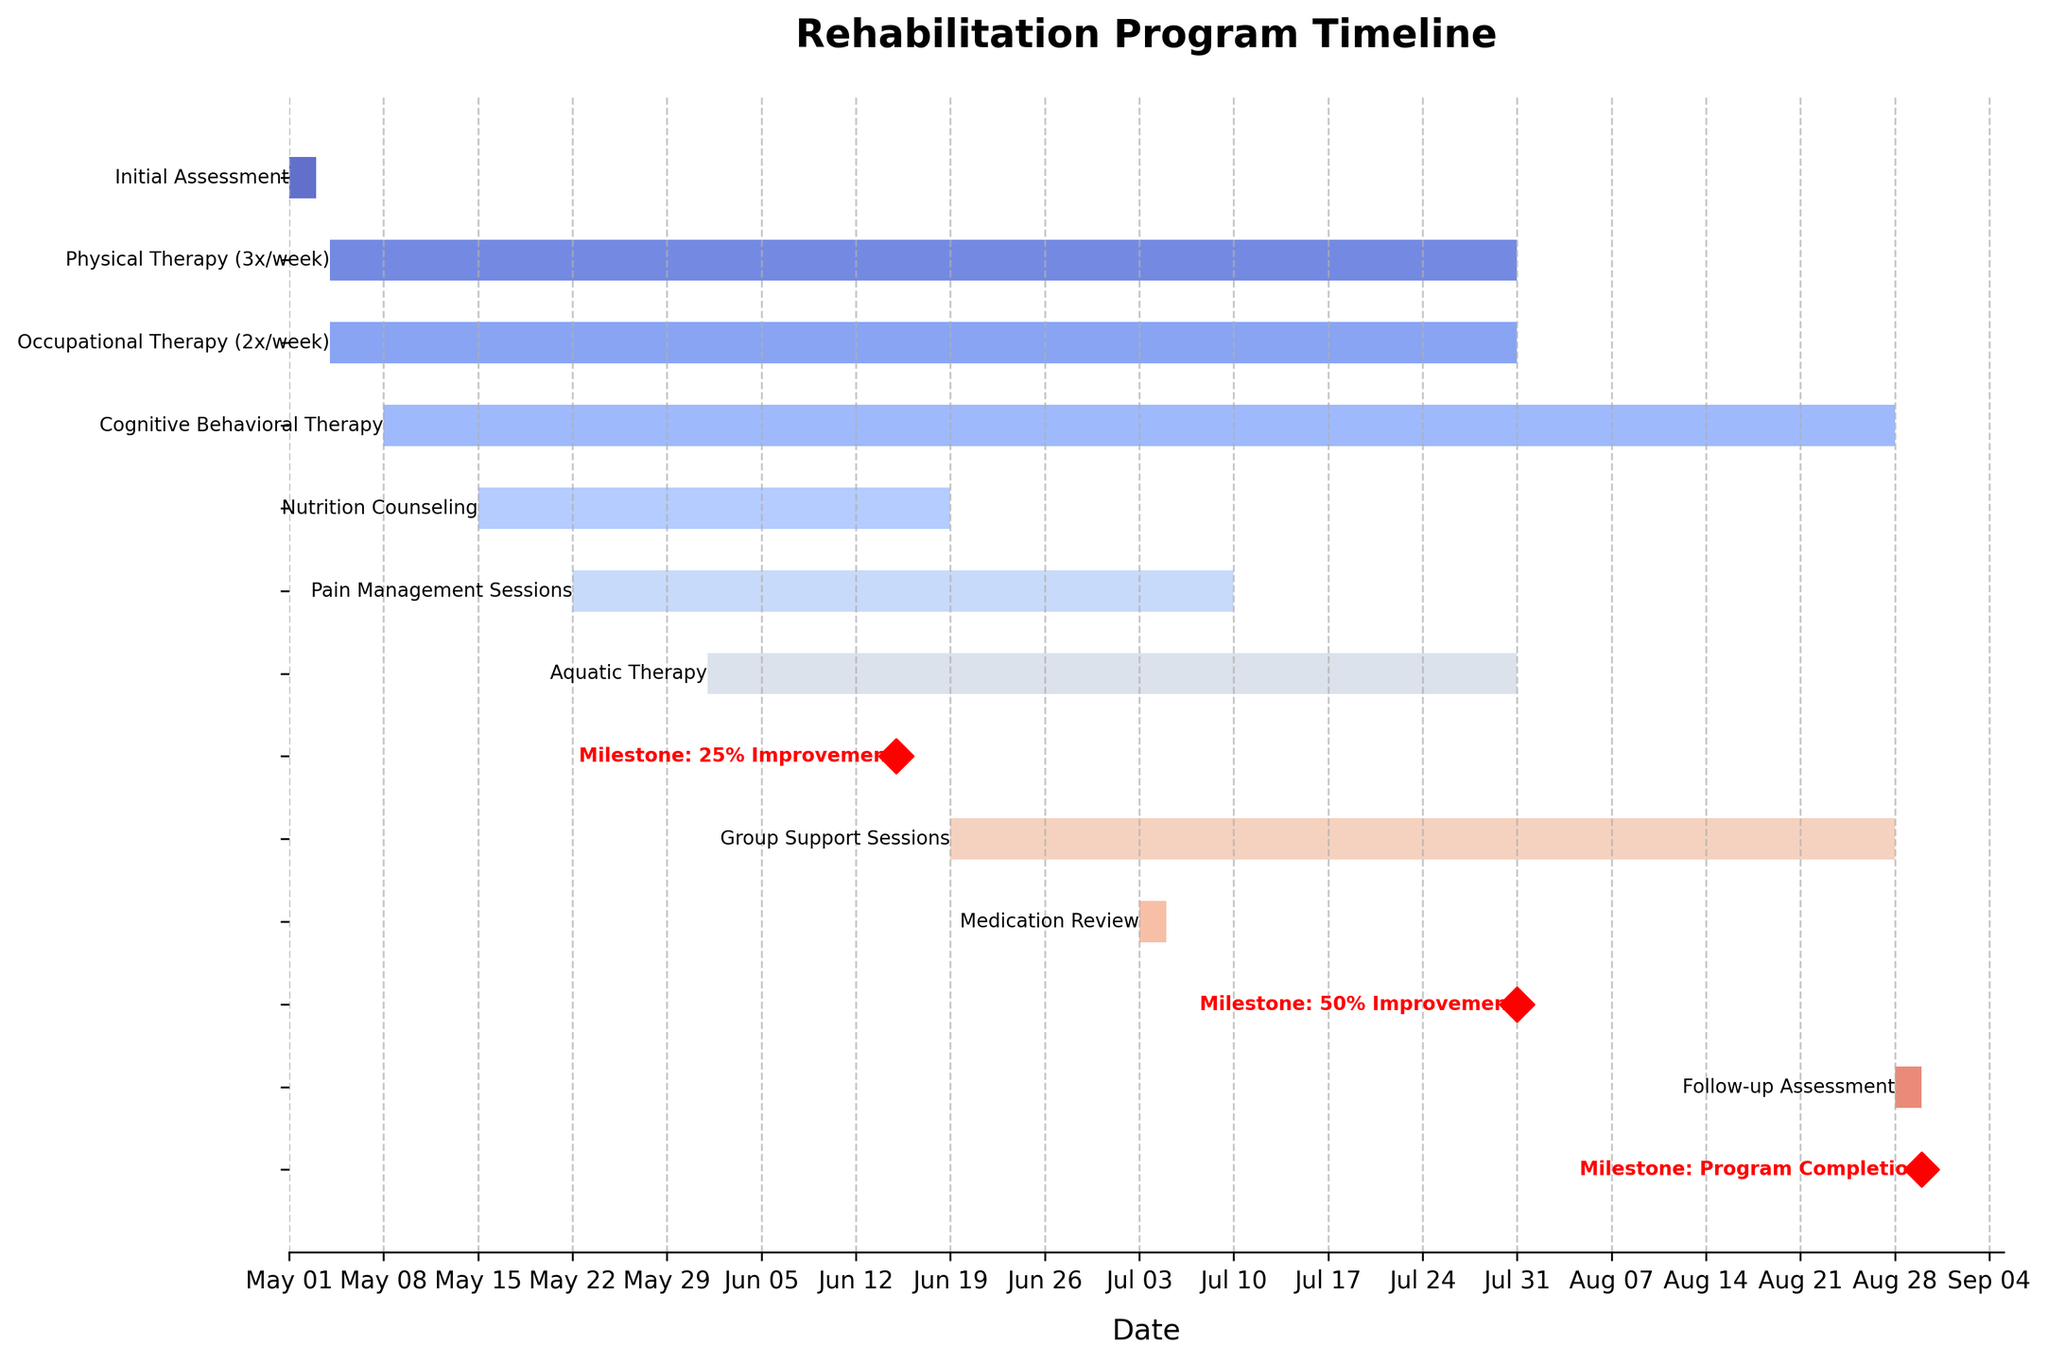What is the title of the chart? The title is usually displayed prominently at the top of the chart. In this case, it reads "Rehabilitation Program Timeline."
Answer: Rehabilitation Program Timeline Which milestone is achieved first according to the chart? To determine this, identify all the milestone labels and their corresponding dates. The earliest milestone is "Milestone: 25% Improvement" on June 15, 2023.
Answer: Milestone: 25% Improvement How long does the Physical Therapy (3x/week) session last? The duration is calculated by subtracting the start date from the end date. The Physical Therapy starts on May 4, 2023, and ends on July 31, 2023. The gap is from May 4 to July 31, which is 88 days.
Answer: 88 days Which sessions or tasks overlap with the Nutrition Counseling session? The Nutrition Counseling session runs from May 15, 2023, to June 19, 2023. Overlapping tasks within this period include Physical Therapy, Occupational Therapy, Cognitive Behavioral Therapy, and Pain Management Sessions.
Answer: Physical Therapy, Occupational Therapy, Cognitive Behavioral Therapy, Pain Management Sessions What is the duration of the longest individual session? Review the lengths of all sessions by checking the dates. Cognitive Behavioral Therapy, lasting from May 8, 2023, to August 28, 2023, is the longest session, spanning 113 days.
Answer: 113 days Which milestone is achieved on the same day as the Follow-up Assessment? Look for milestones and their dates, and match them with other sessions. "Milestone: Program Completion" and the "Follow-up Assessment" both occur on August 30, 2023.
Answer: Milestone: Program Completion How many therapy sessions start in May? Count all tasks and sessions with a start date in May by referring to the Start Date column. Seven therapy sessions begin in May: Initial Assessment, Physical Therapy, Occupational Therapy, Cognitive Behavioral Therapy, Nutrition Counseling, Pain Management Sessions, and Aquatic Therapy.
Answer: 7 What is the difference in days between the start of Group Support Sessions and Follow-up Assessment? Calculate the difference between the start date of Group Support Sessions (June 19, 2023) and the Follow-up Assessment start date (August 28, 2023). This is a 70-day difference.
Answer: 70 days 